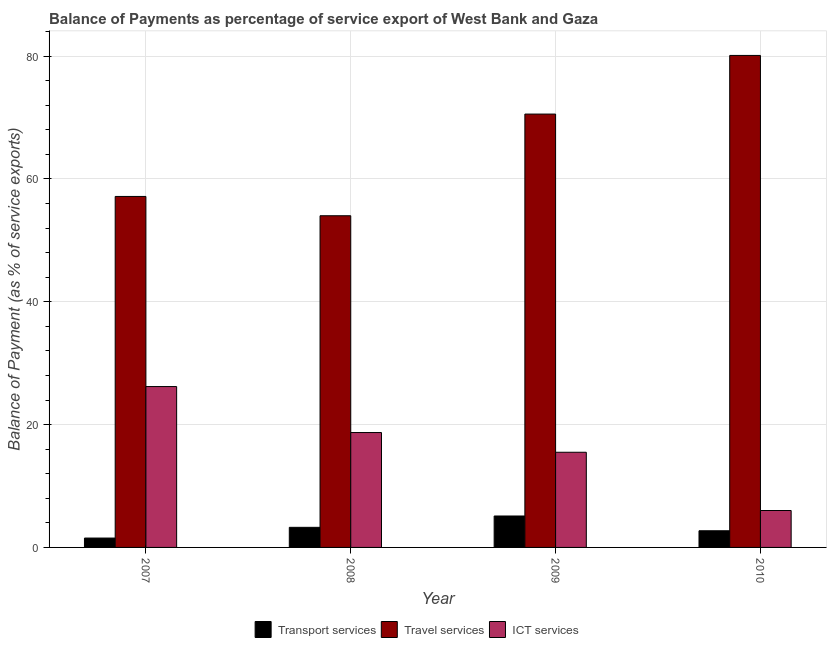How many groups of bars are there?
Make the answer very short. 4. Are the number of bars per tick equal to the number of legend labels?
Provide a succinct answer. Yes. Are the number of bars on each tick of the X-axis equal?
Your answer should be very brief. Yes. How many bars are there on the 2nd tick from the right?
Give a very brief answer. 3. What is the balance of payment of travel services in 2009?
Give a very brief answer. 70.56. Across all years, what is the maximum balance of payment of ict services?
Provide a succinct answer. 26.19. Across all years, what is the minimum balance of payment of ict services?
Give a very brief answer. 6.01. In which year was the balance of payment of ict services minimum?
Provide a short and direct response. 2010. What is the total balance of payment of ict services in the graph?
Offer a very short reply. 66.4. What is the difference between the balance of payment of travel services in 2007 and that in 2010?
Offer a terse response. -22.96. What is the difference between the balance of payment of travel services in 2007 and the balance of payment of transport services in 2009?
Ensure brevity in your answer.  -13.41. What is the average balance of payment of transport services per year?
Provide a short and direct response. 3.16. In the year 2007, what is the difference between the balance of payment of ict services and balance of payment of transport services?
Ensure brevity in your answer.  0. In how many years, is the balance of payment of transport services greater than 72 %?
Your response must be concise. 0. What is the ratio of the balance of payment of transport services in 2009 to that in 2010?
Offer a terse response. 1.89. Is the difference between the balance of payment of transport services in 2007 and 2009 greater than the difference between the balance of payment of travel services in 2007 and 2009?
Your answer should be compact. No. What is the difference between the highest and the second highest balance of payment of ict services?
Provide a short and direct response. 7.49. What is the difference between the highest and the lowest balance of payment of ict services?
Provide a short and direct response. 20.18. What does the 2nd bar from the left in 2008 represents?
Provide a succinct answer. Travel services. What does the 3rd bar from the right in 2007 represents?
Give a very brief answer. Transport services. Are all the bars in the graph horizontal?
Your answer should be compact. No. Are the values on the major ticks of Y-axis written in scientific E-notation?
Provide a succinct answer. No. Does the graph contain any zero values?
Your answer should be compact. No. How many legend labels are there?
Your response must be concise. 3. How are the legend labels stacked?
Give a very brief answer. Horizontal. What is the title of the graph?
Provide a short and direct response. Balance of Payments as percentage of service export of West Bank and Gaza. Does "Taxes on goods and services" appear as one of the legend labels in the graph?
Your answer should be compact. No. What is the label or title of the Y-axis?
Ensure brevity in your answer.  Balance of Payment (as % of service exports). What is the Balance of Payment (as % of service exports) in Transport services in 2007?
Keep it short and to the point. 1.53. What is the Balance of Payment (as % of service exports) in Travel services in 2007?
Your response must be concise. 57.14. What is the Balance of Payment (as % of service exports) in ICT services in 2007?
Provide a short and direct response. 26.19. What is the Balance of Payment (as % of service exports) of Transport services in 2008?
Offer a very short reply. 3.27. What is the Balance of Payment (as % of service exports) of Travel services in 2008?
Provide a succinct answer. 54. What is the Balance of Payment (as % of service exports) of ICT services in 2008?
Your answer should be compact. 18.7. What is the Balance of Payment (as % of service exports) of Transport services in 2009?
Your answer should be very brief. 5.12. What is the Balance of Payment (as % of service exports) of Travel services in 2009?
Your response must be concise. 70.56. What is the Balance of Payment (as % of service exports) in ICT services in 2009?
Keep it short and to the point. 15.49. What is the Balance of Payment (as % of service exports) in Transport services in 2010?
Provide a short and direct response. 2.71. What is the Balance of Payment (as % of service exports) of Travel services in 2010?
Provide a short and direct response. 80.1. What is the Balance of Payment (as % of service exports) in ICT services in 2010?
Your response must be concise. 6.01. Across all years, what is the maximum Balance of Payment (as % of service exports) of Transport services?
Provide a succinct answer. 5.12. Across all years, what is the maximum Balance of Payment (as % of service exports) of Travel services?
Your answer should be compact. 80.1. Across all years, what is the maximum Balance of Payment (as % of service exports) of ICT services?
Ensure brevity in your answer.  26.19. Across all years, what is the minimum Balance of Payment (as % of service exports) in Transport services?
Your response must be concise. 1.53. Across all years, what is the minimum Balance of Payment (as % of service exports) of Travel services?
Keep it short and to the point. 54. Across all years, what is the minimum Balance of Payment (as % of service exports) in ICT services?
Provide a succinct answer. 6.01. What is the total Balance of Payment (as % of service exports) of Transport services in the graph?
Provide a short and direct response. 12.63. What is the total Balance of Payment (as % of service exports) in Travel services in the graph?
Provide a short and direct response. 261.81. What is the total Balance of Payment (as % of service exports) in ICT services in the graph?
Keep it short and to the point. 66.4. What is the difference between the Balance of Payment (as % of service exports) in Transport services in 2007 and that in 2008?
Keep it short and to the point. -1.75. What is the difference between the Balance of Payment (as % of service exports) in Travel services in 2007 and that in 2008?
Your answer should be compact. 3.14. What is the difference between the Balance of Payment (as % of service exports) in ICT services in 2007 and that in 2008?
Give a very brief answer. 7.49. What is the difference between the Balance of Payment (as % of service exports) of Transport services in 2007 and that in 2009?
Offer a very short reply. -3.59. What is the difference between the Balance of Payment (as % of service exports) of Travel services in 2007 and that in 2009?
Provide a succinct answer. -13.41. What is the difference between the Balance of Payment (as % of service exports) in ICT services in 2007 and that in 2009?
Your answer should be compact. 10.7. What is the difference between the Balance of Payment (as % of service exports) of Transport services in 2007 and that in 2010?
Ensure brevity in your answer.  -1.19. What is the difference between the Balance of Payment (as % of service exports) of Travel services in 2007 and that in 2010?
Give a very brief answer. -22.96. What is the difference between the Balance of Payment (as % of service exports) of ICT services in 2007 and that in 2010?
Your answer should be very brief. 20.18. What is the difference between the Balance of Payment (as % of service exports) in Transport services in 2008 and that in 2009?
Offer a terse response. -1.85. What is the difference between the Balance of Payment (as % of service exports) of Travel services in 2008 and that in 2009?
Your answer should be compact. -16.55. What is the difference between the Balance of Payment (as % of service exports) in ICT services in 2008 and that in 2009?
Offer a very short reply. 3.21. What is the difference between the Balance of Payment (as % of service exports) in Transport services in 2008 and that in 2010?
Your answer should be compact. 0.56. What is the difference between the Balance of Payment (as % of service exports) of Travel services in 2008 and that in 2010?
Your answer should be compact. -26.1. What is the difference between the Balance of Payment (as % of service exports) of ICT services in 2008 and that in 2010?
Provide a succinct answer. 12.69. What is the difference between the Balance of Payment (as % of service exports) of Transport services in 2009 and that in 2010?
Give a very brief answer. 2.4. What is the difference between the Balance of Payment (as % of service exports) in Travel services in 2009 and that in 2010?
Your answer should be very brief. -9.55. What is the difference between the Balance of Payment (as % of service exports) of ICT services in 2009 and that in 2010?
Your answer should be very brief. 9.48. What is the difference between the Balance of Payment (as % of service exports) in Transport services in 2007 and the Balance of Payment (as % of service exports) in Travel services in 2008?
Provide a succinct answer. -52.48. What is the difference between the Balance of Payment (as % of service exports) in Transport services in 2007 and the Balance of Payment (as % of service exports) in ICT services in 2008?
Give a very brief answer. -17.18. What is the difference between the Balance of Payment (as % of service exports) in Travel services in 2007 and the Balance of Payment (as % of service exports) in ICT services in 2008?
Your response must be concise. 38.44. What is the difference between the Balance of Payment (as % of service exports) of Transport services in 2007 and the Balance of Payment (as % of service exports) of Travel services in 2009?
Make the answer very short. -69.03. What is the difference between the Balance of Payment (as % of service exports) in Transport services in 2007 and the Balance of Payment (as % of service exports) in ICT services in 2009?
Provide a succinct answer. -13.97. What is the difference between the Balance of Payment (as % of service exports) of Travel services in 2007 and the Balance of Payment (as % of service exports) of ICT services in 2009?
Keep it short and to the point. 41.65. What is the difference between the Balance of Payment (as % of service exports) of Transport services in 2007 and the Balance of Payment (as % of service exports) of Travel services in 2010?
Offer a terse response. -78.58. What is the difference between the Balance of Payment (as % of service exports) of Transport services in 2007 and the Balance of Payment (as % of service exports) of ICT services in 2010?
Give a very brief answer. -4.48. What is the difference between the Balance of Payment (as % of service exports) in Travel services in 2007 and the Balance of Payment (as % of service exports) in ICT services in 2010?
Offer a terse response. 51.13. What is the difference between the Balance of Payment (as % of service exports) in Transport services in 2008 and the Balance of Payment (as % of service exports) in Travel services in 2009?
Your answer should be very brief. -67.28. What is the difference between the Balance of Payment (as % of service exports) of Transport services in 2008 and the Balance of Payment (as % of service exports) of ICT services in 2009?
Your response must be concise. -12.22. What is the difference between the Balance of Payment (as % of service exports) of Travel services in 2008 and the Balance of Payment (as % of service exports) of ICT services in 2009?
Keep it short and to the point. 38.51. What is the difference between the Balance of Payment (as % of service exports) in Transport services in 2008 and the Balance of Payment (as % of service exports) in Travel services in 2010?
Your answer should be compact. -76.83. What is the difference between the Balance of Payment (as % of service exports) of Transport services in 2008 and the Balance of Payment (as % of service exports) of ICT services in 2010?
Your response must be concise. -2.74. What is the difference between the Balance of Payment (as % of service exports) of Travel services in 2008 and the Balance of Payment (as % of service exports) of ICT services in 2010?
Offer a very short reply. 47.99. What is the difference between the Balance of Payment (as % of service exports) in Transport services in 2009 and the Balance of Payment (as % of service exports) in Travel services in 2010?
Your answer should be compact. -74.99. What is the difference between the Balance of Payment (as % of service exports) of Transport services in 2009 and the Balance of Payment (as % of service exports) of ICT services in 2010?
Your response must be concise. -0.89. What is the difference between the Balance of Payment (as % of service exports) of Travel services in 2009 and the Balance of Payment (as % of service exports) of ICT services in 2010?
Keep it short and to the point. 64.55. What is the average Balance of Payment (as % of service exports) of Transport services per year?
Your answer should be compact. 3.16. What is the average Balance of Payment (as % of service exports) in Travel services per year?
Offer a terse response. 65.45. What is the average Balance of Payment (as % of service exports) of ICT services per year?
Give a very brief answer. 16.6. In the year 2007, what is the difference between the Balance of Payment (as % of service exports) of Transport services and Balance of Payment (as % of service exports) of Travel services?
Your answer should be compact. -55.62. In the year 2007, what is the difference between the Balance of Payment (as % of service exports) in Transport services and Balance of Payment (as % of service exports) in ICT services?
Offer a terse response. -24.67. In the year 2007, what is the difference between the Balance of Payment (as % of service exports) of Travel services and Balance of Payment (as % of service exports) of ICT services?
Your response must be concise. 30.95. In the year 2008, what is the difference between the Balance of Payment (as % of service exports) in Transport services and Balance of Payment (as % of service exports) in Travel services?
Your answer should be very brief. -50.73. In the year 2008, what is the difference between the Balance of Payment (as % of service exports) in Transport services and Balance of Payment (as % of service exports) in ICT services?
Provide a succinct answer. -15.43. In the year 2008, what is the difference between the Balance of Payment (as % of service exports) of Travel services and Balance of Payment (as % of service exports) of ICT services?
Provide a succinct answer. 35.3. In the year 2009, what is the difference between the Balance of Payment (as % of service exports) of Transport services and Balance of Payment (as % of service exports) of Travel services?
Give a very brief answer. -65.44. In the year 2009, what is the difference between the Balance of Payment (as % of service exports) in Transport services and Balance of Payment (as % of service exports) in ICT services?
Offer a terse response. -10.38. In the year 2009, what is the difference between the Balance of Payment (as % of service exports) in Travel services and Balance of Payment (as % of service exports) in ICT services?
Your response must be concise. 55.06. In the year 2010, what is the difference between the Balance of Payment (as % of service exports) of Transport services and Balance of Payment (as % of service exports) of Travel services?
Make the answer very short. -77.39. In the year 2010, what is the difference between the Balance of Payment (as % of service exports) in Transport services and Balance of Payment (as % of service exports) in ICT services?
Ensure brevity in your answer.  -3.3. In the year 2010, what is the difference between the Balance of Payment (as % of service exports) in Travel services and Balance of Payment (as % of service exports) in ICT services?
Offer a very short reply. 74.09. What is the ratio of the Balance of Payment (as % of service exports) in Transport services in 2007 to that in 2008?
Your answer should be very brief. 0.47. What is the ratio of the Balance of Payment (as % of service exports) in Travel services in 2007 to that in 2008?
Make the answer very short. 1.06. What is the ratio of the Balance of Payment (as % of service exports) in ICT services in 2007 to that in 2008?
Provide a short and direct response. 1.4. What is the ratio of the Balance of Payment (as % of service exports) of Transport services in 2007 to that in 2009?
Your answer should be compact. 0.3. What is the ratio of the Balance of Payment (as % of service exports) of Travel services in 2007 to that in 2009?
Your response must be concise. 0.81. What is the ratio of the Balance of Payment (as % of service exports) of ICT services in 2007 to that in 2009?
Provide a short and direct response. 1.69. What is the ratio of the Balance of Payment (as % of service exports) of Transport services in 2007 to that in 2010?
Make the answer very short. 0.56. What is the ratio of the Balance of Payment (as % of service exports) of Travel services in 2007 to that in 2010?
Offer a terse response. 0.71. What is the ratio of the Balance of Payment (as % of service exports) in ICT services in 2007 to that in 2010?
Give a very brief answer. 4.36. What is the ratio of the Balance of Payment (as % of service exports) of Transport services in 2008 to that in 2009?
Make the answer very short. 0.64. What is the ratio of the Balance of Payment (as % of service exports) of Travel services in 2008 to that in 2009?
Keep it short and to the point. 0.77. What is the ratio of the Balance of Payment (as % of service exports) in ICT services in 2008 to that in 2009?
Your answer should be very brief. 1.21. What is the ratio of the Balance of Payment (as % of service exports) in Transport services in 2008 to that in 2010?
Give a very brief answer. 1.21. What is the ratio of the Balance of Payment (as % of service exports) of Travel services in 2008 to that in 2010?
Your response must be concise. 0.67. What is the ratio of the Balance of Payment (as % of service exports) of ICT services in 2008 to that in 2010?
Keep it short and to the point. 3.11. What is the ratio of the Balance of Payment (as % of service exports) of Transport services in 2009 to that in 2010?
Keep it short and to the point. 1.89. What is the ratio of the Balance of Payment (as % of service exports) in Travel services in 2009 to that in 2010?
Ensure brevity in your answer.  0.88. What is the ratio of the Balance of Payment (as % of service exports) in ICT services in 2009 to that in 2010?
Offer a terse response. 2.58. What is the difference between the highest and the second highest Balance of Payment (as % of service exports) in Transport services?
Keep it short and to the point. 1.85. What is the difference between the highest and the second highest Balance of Payment (as % of service exports) in Travel services?
Give a very brief answer. 9.55. What is the difference between the highest and the second highest Balance of Payment (as % of service exports) of ICT services?
Provide a short and direct response. 7.49. What is the difference between the highest and the lowest Balance of Payment (as % of service exports) of Transport services?
Your answer should be compact. 3.59. What is the difference between the highest and the lowest Balance of Payment (as % of service exports) of Travel services?
Make the answer very short. 26.1. What is the difference between the highest and the lowest Balance of Payment (as % of service exports) in ICT services?
Provide a short and direct response. 20.18. 